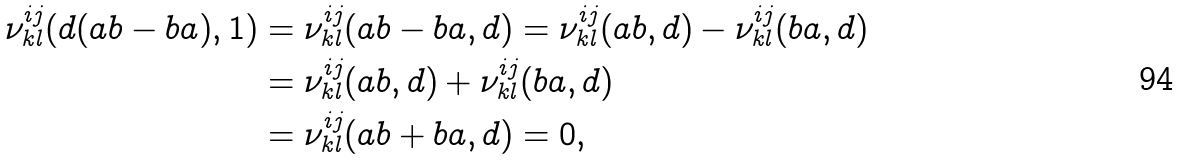<formula> <loc_0><loc_0><loc_500><loc_500>\nu ^ { i j } _ { k l } ( d ( a b - b a ) , 1 ) & = \nu ^ { i j } _ { k l } ( a b - b a , d ) = \nu ^ { i j } _ { k l } ( a b , d ) - \nu ^ { i j } _ { k l } ( b a , d ) \\ & = \nu ^ { i j } _ { k l } ( a b , d ) + \nu ^ { i j } _ { k l } ( b a , d ) \\ & = \nu ^ { i j } _ { k l } ( a b + b a , d ) = 0 ,</formula> 